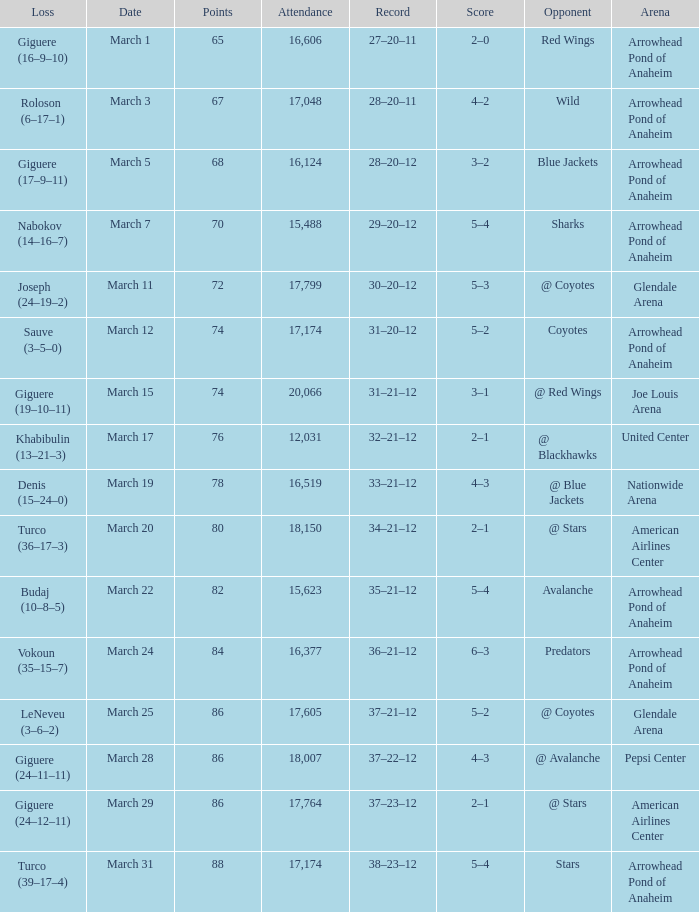What is the Loss of the game at Nationwide Arena with a Score of 4–3? Denis (15–24–0). Write the full table. {'header': ['Loss', 'Date', 'Points', 'Attendance', 'Record', 'Score', 'Opponent', 'Arena'], 'rows': [['Giguere (16–9–10)', 'March 1', '65', '16,606', '27–20–11', '2–0', 'Red Wings', 'Arrowhead Pond of Anaheim'], ['Roloson (6–17–1)', 'March 3', '67', '17,048', '28–20–11', '4–2', 'Wild', 'Arrowhead Pond of Anaheim'], ['Giguere (17–9–11)', 'March 5', '68', '16,124', '28–20–12', '3–2', 'Blue Jackets', 'Arrowhead Pond of Anaheim'], ['Nabokov (14–16–7)', 'March 7', '70', '15,488', '29–20–12', '5–4', 'Sharks', 'Arrowhead Pond of Anaheim'], ['Joseph (24–19–2)', 'March 11', '72', '17,799', '30–20–12', '5–3', '@ Coyotes', 'Glendale Arena'], ['Sauve (3–5–0)', 'March 12', '74', '17,174', '31–20–12', '5–2', 'Coyotes', 'Arrowhead Pond of Anaheim'], ['Giguere (19–10–11)', 'March 15', '74', '20,066', '31–21–12', '3–1', '@ Red Wings', 'Joe Louis Arena'], ['Khabibulin (13–21–3)', 'March 17', '76', '12,031', '32–21–12', '2–1', '@ Blackhawks', 'United Center'], ['Denis (15–24–0)', 'March 19', '78', '16,519', '33–21–12', '4–3', '@ Blue Jackets', 'Nationwide Arena'], ['Turco (36–17–3)', 'March 20', '80', '18,150', '34–21–12', '2–1', '@ Stars', 'American Airlines Center'], ['Budaj (10–8–5)', 'March 22', '82', '15,623', '35–21–12', '5–4', 'Avalanche', 'Arrowhead Pond of Anaheim'], ['Vokoun (35–15–7)', 'March 24', '84', '16,377', '36–21–12', '6–3', 'Predators', 'Arrowhead Pond of Anaheim'], ['LeNeveu (3–6–2)', 'March 25', '86', '17,605', '37–21–12', '5–2', '@ Coyotes', 'Glendale Arena'], ['Giguere (24–11–11)', 'March 28', '86', '18,007', '37–22–12', '4–3', '@ Avalanche', 'Pepsi Center'], ['Giguere (24–12–11)', 'March 29', '86', '17,764', '37–23–12', '2–1', '@ Stars', 'American Airlines Center'], ['Turco (39–17–4)', 'March 31', '88', '17,174', '38–23–12', '5–4', 'Stars', 'Arrowhead Pond of Anaheim']]} 